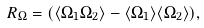<formula> <loc_0><loc_0><loc_500><loc_500>R _ { \Omega } = ( \langle \Omega _ { 1 } \Omega _ { 2 } \rangle - \langle \Omega _ { 1 } \rangle \langle \Omega _ { 2 } \rangle ) ,</formula> 